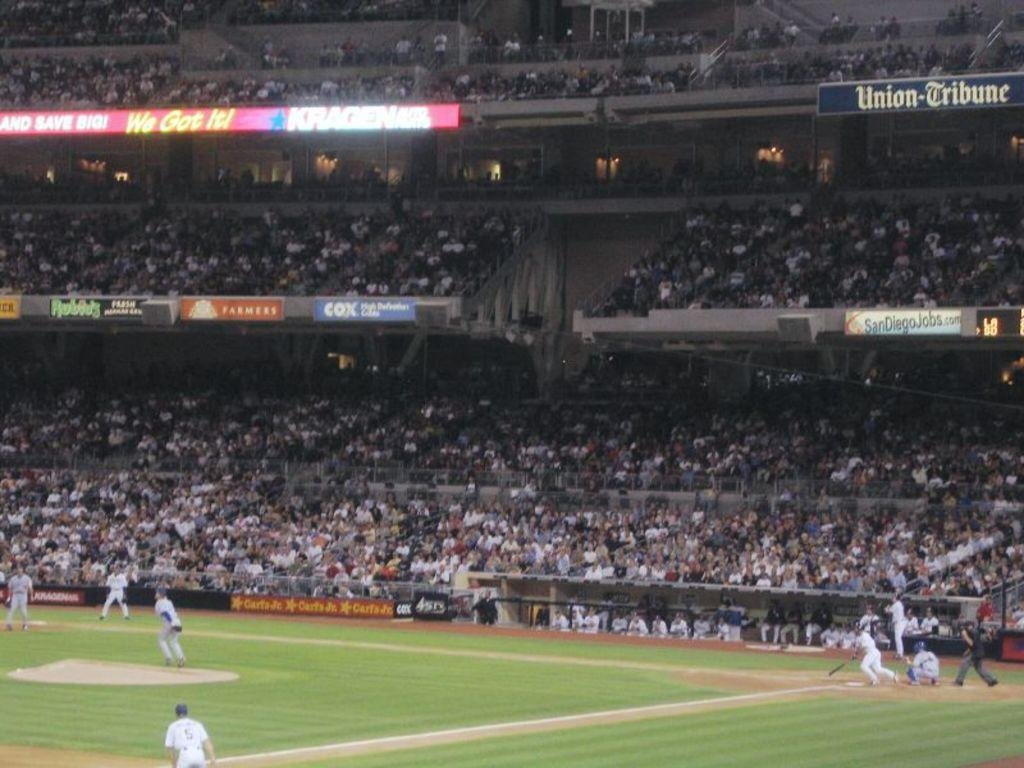<image>
Give a short and clear explanation of the subsequent image. A baseball stadium with several banners advertising companies including COX. 